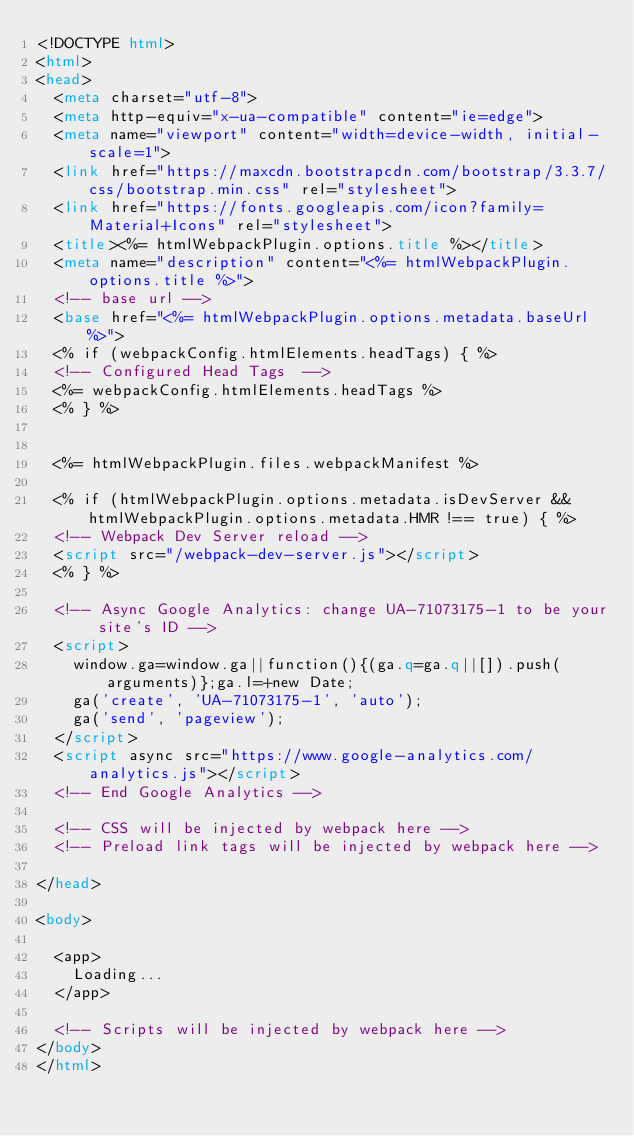<code> <loc_0><loc_0><loc_500><loc_500><_HTML_><!DOCTYPE html>
<html>
<head>
  <meta charset="utf-8">
  <meta http-equiv="x-ua-compatible" content="ie=edge">
  <meta name="viewport" content="width=device-width, initial-scale=1">
  <link href="https://maxcdn.bootstrapcdn.com/bootstrap/3.3.7/css/bootstrap.min.css" rel="stylesheet">
  <link href="https://fonts.googleapis.com/icon?family=Material+Icons" rel="stylesheet">
  <title><%= htmlWebpackPlugin.options.title %></title>
  <meta name="description" content="<%= htmlWebpackPlugin.options.title %>">
  <!-- base url -->
  <base href="<%= htmlWebpackPlugin.options.metadata.baseUrl %>">
  <% if (webpackConfig.htmlElements.headTags) { %>
  <!-- Configured Head Tags  -->
  <%= webpackConfig.htmlElements.headTags %>
  <% } %>


  <%= htmlWebpackPlugin.files.webpackManifest %>

  <% if (htmlWebpackPlugin.options.metadata.isDevServer && htmlWebpackPlugin.options.metadata.HMR !== true) { %>
  <!-- Webpack Dev Server reload -->
  <script src="/webpack-dev-server.js"></script>
  <% } %>

  <!-- Async Google Analytics: change UA-71073175-1 to be your site's ID -->
  <script>
    window.ga=window.ga||function(){(ga.q=ga.q||[]).push(arguments)};ga.l=+new Date;
    ga('create', 'UA-71073175-1', 'auto');
    ga('send', 'pageview');
  </script>
  <script async src="https://www.google-analytics.com/analytics.js"></script>
  <!-- End Google Analytics -->

  <!-- CSS will be injected by webpack here -->
  <!-- Preload link tags will be injected by webpack here -->

</head>

<body>

  <app>
    Loading...
  </app>

  <!-- Scripts will be injected by webpack here -->
</body>
</html>
</code> 